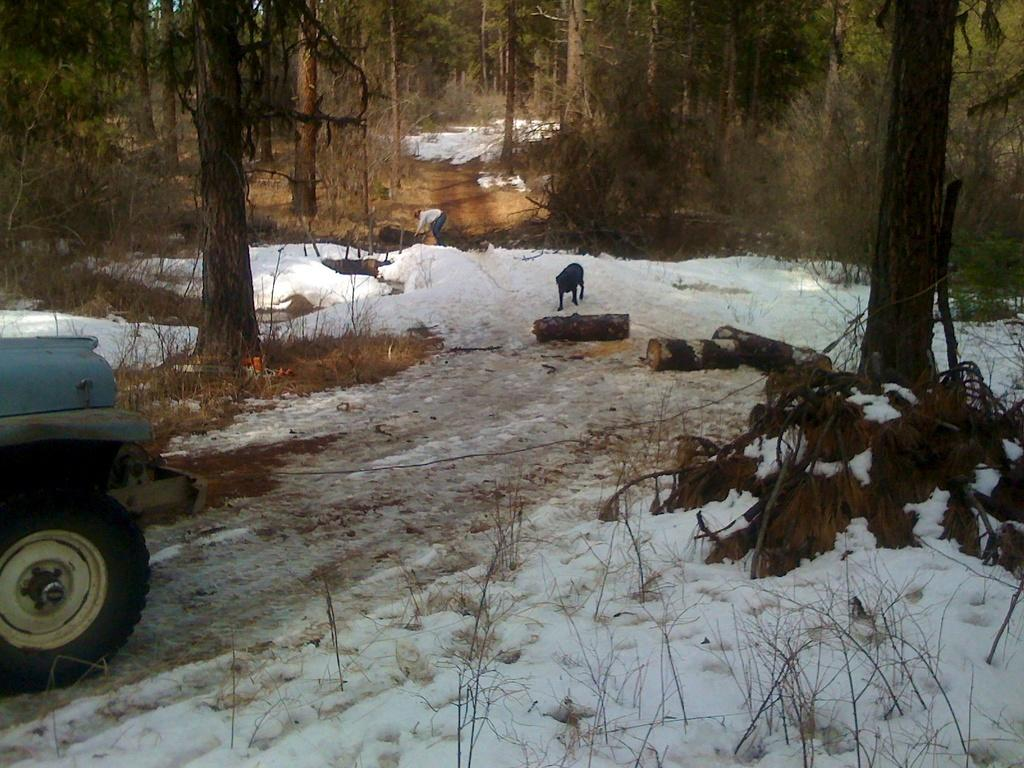What type of animal is in the image? There is a dog in the image. Who or what else is in the image? There is a person in the image. What object is on the floor in the image? There is a car on the floor in the image. What is the condition of the floor in the image? The floor has snow in the image. What type of vegetation can be seen in the image? There are trees and plants in the image. What type of scissors are being used by the person in the image? There are no scissors present in the image. What is the relation between the dog and the person in the image? The provided facts do not give any information about the relationship between the dog and the person in the image. 